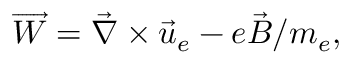<formula> <loc_0><loc_0><loc_500><loc_500>\overrightarrow { W } = \vec { \nabla } \times \vec { u } _ { e } - e \vec { B } / m _ { e } ,</formula> 